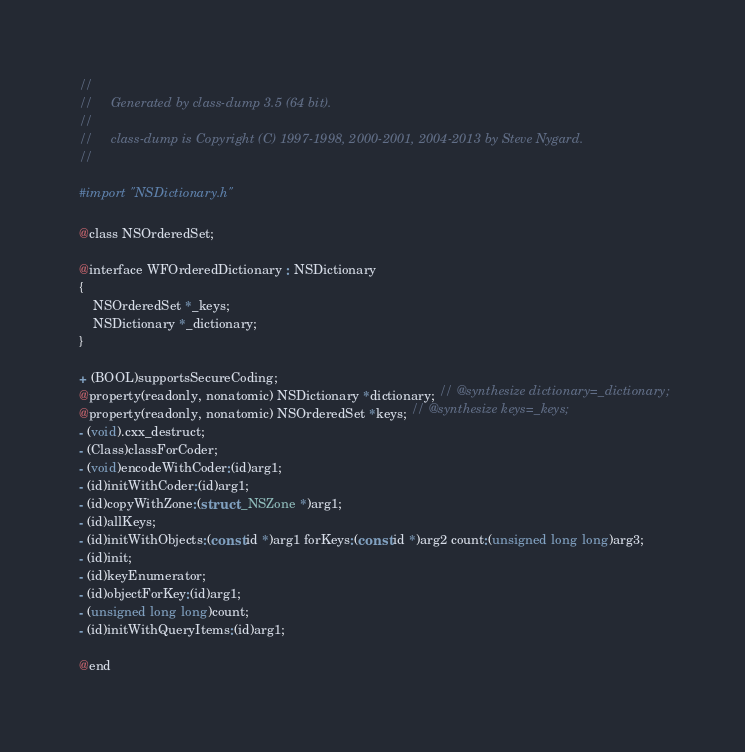<code> <loc_0><loc_0><loc_500><loc_500><_C_>//
//     Generated by class-dump 3.5 (64 bit).
//
//     class-dump is Copyright (C) 1997-1998, 2000-2001, 2004-2013 by Steve Nygard.
//

#import "NSDictionary.h"

@class NSOrderedSet;

@interface WFOrderedDictionary : NSDictionary
{
    NSOrderedSet *_keys;
    NSDictionary *_dictionary;
}

+ (BOOL)supportsSecureCoding;
@property(readonly, nonatomic) NSDictionary *dictionary; // @synthesize dictionary=_dictionary;
@property(readonly, nonatomic) NSOrderedSet *keys; // @synthesize keys=_keys;
- (void).cxx_destruct;
- (Class)classForCoder;
- (void)encodeWithCoder:(id)arg1;
- (id)initWithCoder:(id)arg1;
- (id)copyWithZone:(struct _NSZone *)arg1;
- (id)allKeys;
- (id)initWithObjects:(const id *)arg1 forKeys:(const id *)arg2 count:(unsigned long long)arg3;
- (id)init;
- (id)keyEnumerator;
- (id)objectForKey:(id)arg1;
- (unsigned long long)count;
- (id)initWithQueryItems:(id)arg1;

@end

</code> 